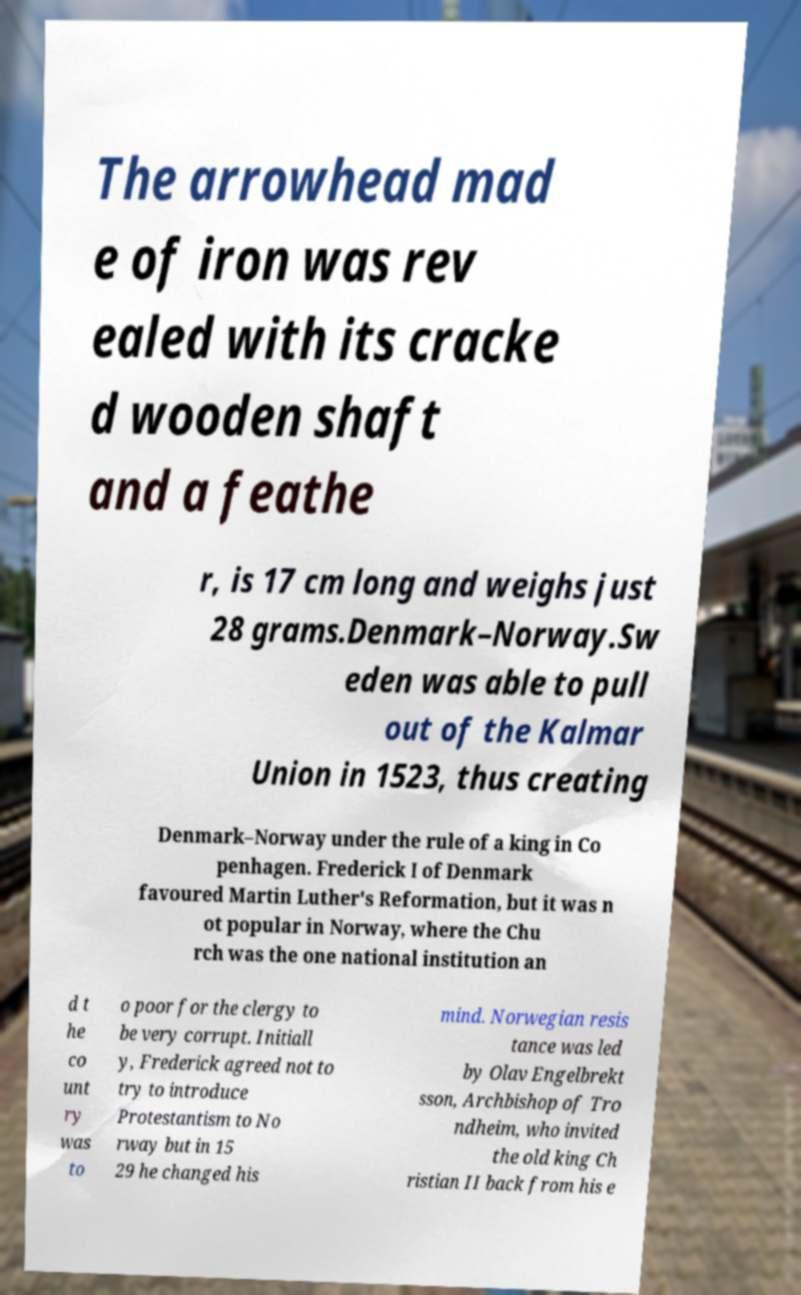Can you read and provide the text displayed in the image?This photo seems to have some interesting text. Can you extract and type it out for me? The arrowhead mad e of iron was rev ealed with its cracke d wooden shaft and a feathe r, is 17 cm long and weighs just 28 grams.Denmark–Norway.Sw eden was able to pull out of the Kalmar Union in 1523, thus creating Denmark–Norway under the rule of a king in Co penhagen. Frederick I of Denmark favoured Martin Luther's Reformation, but it was n ot popular in Norway, where the Chu rch was the one national institution an d t he co unt ry was to o poor for the clergy to be very corrupt. Initiall y, Frederick agreed not to try to introduce Protestantism to No rway but in 15 29 he changed his mind. Norwegian resis tance was led by Olav Engelbrekt sson, Archbishop of Tro ndheim, who invited the old king Ch ristian II back from his e 